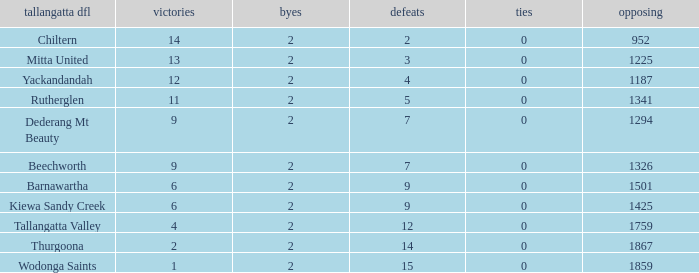What are the fewest draws with less than 7 losses and Mitta United is the Tallagatta DFL? 0.0. 